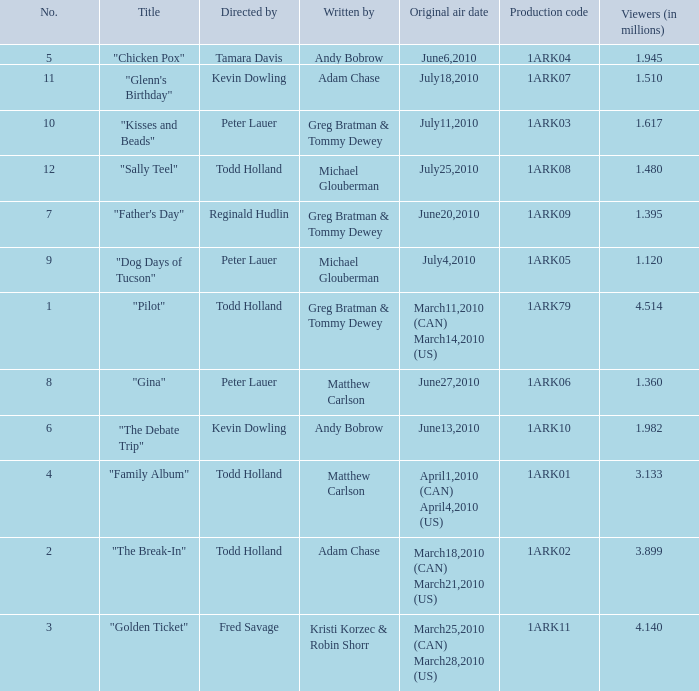What is the original air date for production code 1ark79? March11,2010 (CAN) March14,2010 (US). 